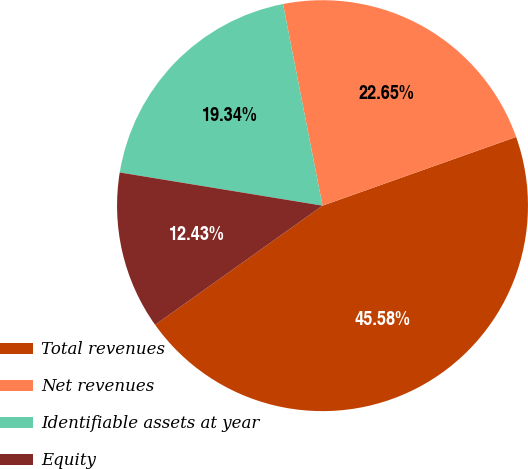Convert chart. <chart><loc_0><loc_0><loc_500><loc_500><pie_chart><fcel>Total revenues<fcel>Net revenues<fcel>Identifiable assets at year<fcel>Equity<nl><fcel>45.58%<fcel>22.65%<fcel>19.34%<fcel>12.43%<nl></chart> 